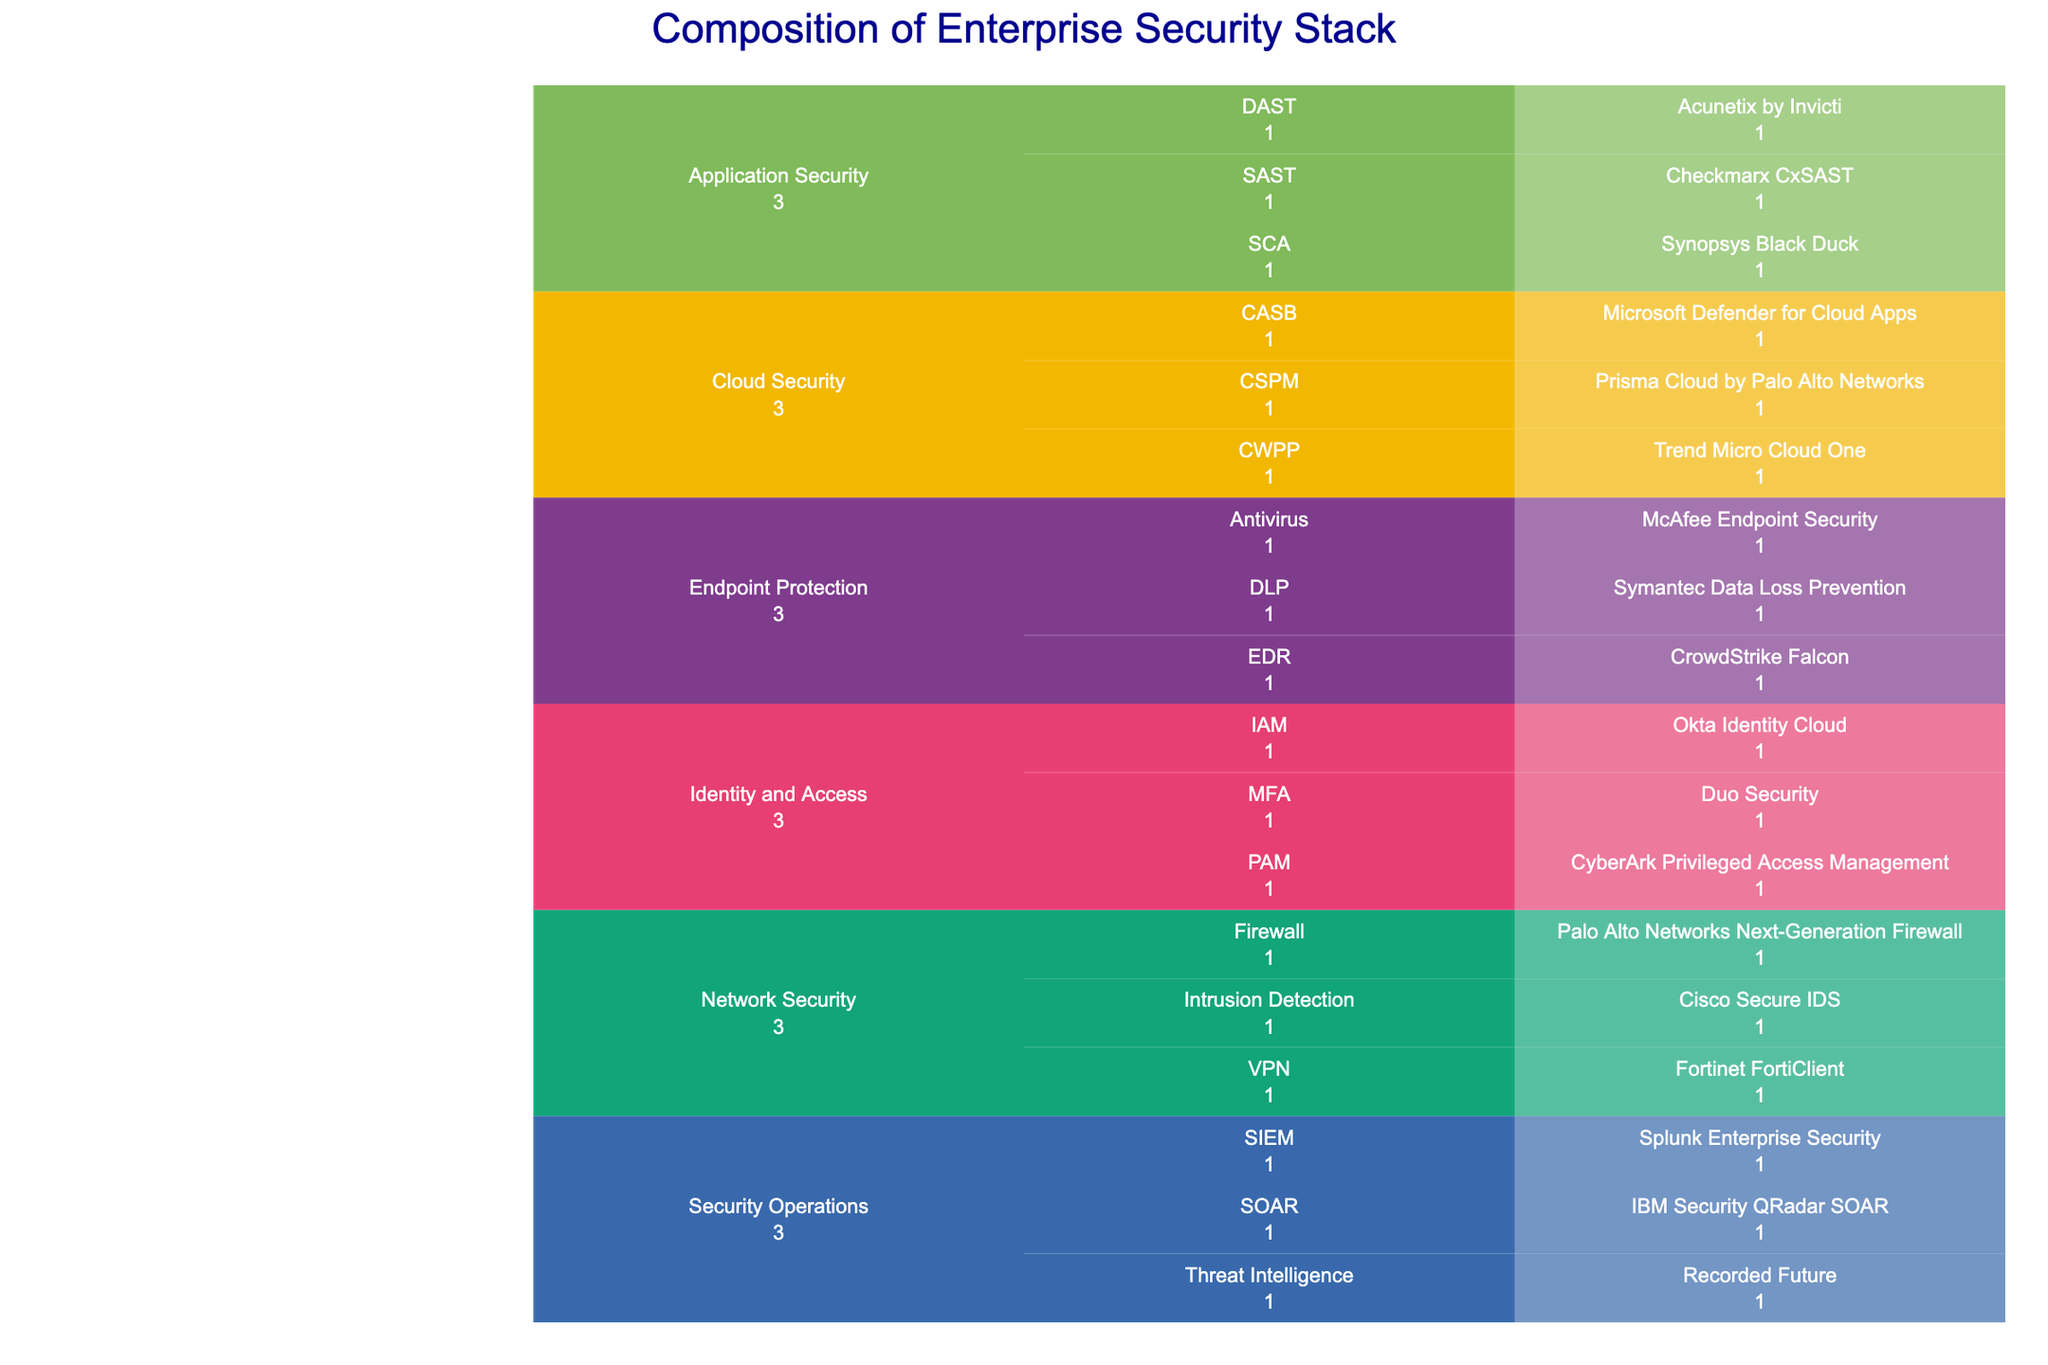What's the title of the icicle chart? The title is usually displayed prominently at the top of the plot. The title summarizes the content of the chart.
Answer: "Composition of Enterprise Security Stack" Which product is highlighted for Application Security in the annotation? There is a clearly visible annotation at the bottom of the chart that highlights a specific product. The annotation is meant to draw attention to that product.
Answer: Checkmarx CxSAST How many categories are there in the security stack? Each major segment or color in the Icicle Chart represents a different category.
Answer: 6 How many subcategories fall under "Network Security"? Network Security is a category, and each branching from it represents a subcategory. Count these subcategories.
Answer: 3 Which subcategory has more than one product listed under "Endpoint Protection"? Endpoint Protection is the main category. Check the number of products under each subcategory. Compare them.
Answer: None What is the vendor of the Intrusion Detection product? Navigate the chart to find the "Intrusion Detection" subcategory under "Network Security". The product and its vendor will be listed.
Answer: Cisco How does the number of IAM products compare to the number of SCA products? Count the products listed under both the IAM (Identity and Access) and SCA (Application Security) subcategories.
Answer: IAM has more products than SCA Which vendors are listed under "Cloud Security"? Identify the Cloud Security category and list the products and their respective vendors.
Answer: Microsoft, Trend Micro, Palo Alto Networks Identify the category with the fewest subcategories. Examine each category and count the subcategories under each. Identify the one with the fewest.
Answer: Security Operations Which Security Operations subcategory has products from IBM? Identify the Security Operations section and locate IBM listed under any subcategory.
Answer: SOAR 